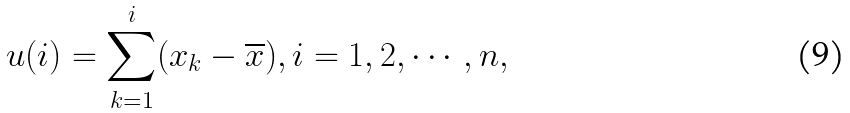<formula> <loc_0><loc_0><loc_500><loc_500>u ( i ) = \sum _ { k = 1 } ^ { i } ( x _ { k } - \overline { x } ) , i = 1 , 2 , \cdots , n ,</formula> 